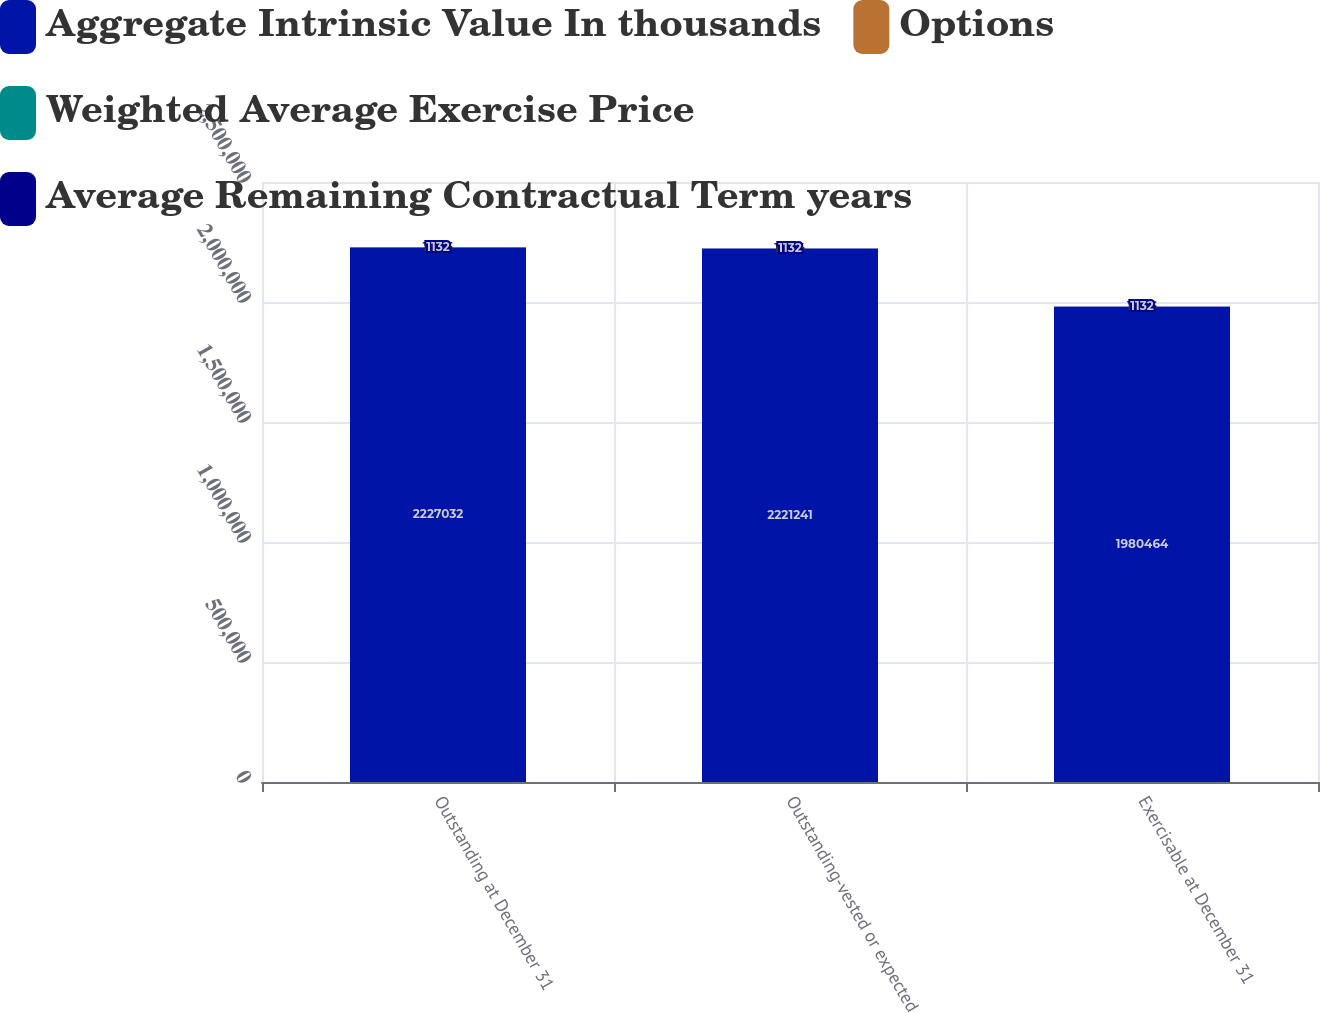Convert chart to OTSL. <chart><loc_0><loc_0><loc_500><loc_500><stacked_bar_chart><ecel><fcel>Outstanding at December 31<fcel>Outstanding-vested or expected<fcel>Exercisable at December 31<nl><fcel>Aggregate Intrinsic Value In thousands<fcel>2.22703e+06<fcel>2.22124e+06<fcel>1.98046e+06<nl><fcel>Options<fcel>19.85<fcel>19.84<fcel>19.36<nl><fcel>Weighted Average Exercise Price<fcel>4.1<fcel>4<fcel>3.9<nl><fcel>Average Remaining Contractual Term years<fcel>1132<fcel>1132<fcel>1132<nl></chart> 